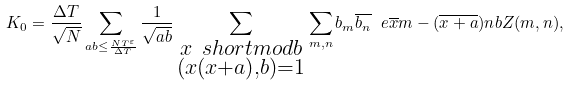Convert formula to latex. <formula><loc_0><loc_0><loc_500><loc_500>K _ { 0 } = \frac { \Delta T } { \sqrt { N } } \sum _ { a b \leq \frac { N T ^ { \varepsilon } } { \Delta T } } \frac { 1 } { \sqrt { a b } } \sum _ { \substack { x \ s h o r t m o d { b } \\ ( x ( x + a ) , b ) = 1 } } \sum _ { m , n } b _ { m } \overline { b _ { n } } \ e { \overline { x } m - ( \overline { x + a } ) n } { b } Z ( m , n ) ,</formula> 